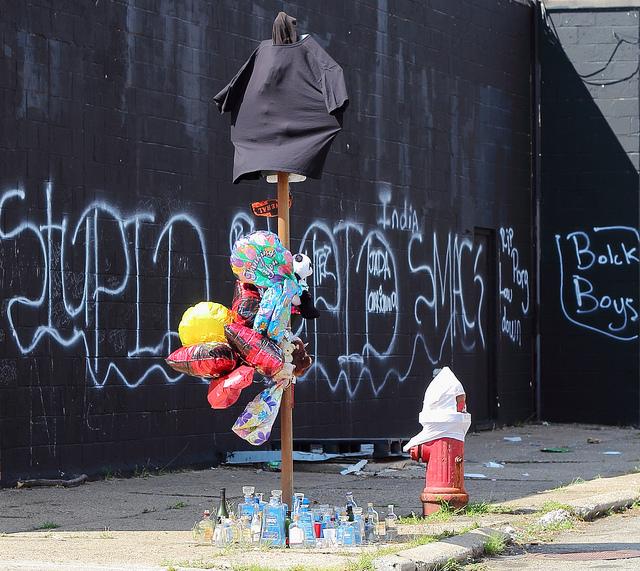What is the primary color of the wall?
Short answer required. Black. What color is the fire hydrant?
Write a very short answer. Red. What is the street art form on the wall called?
Answer briefly. Graffiti. 